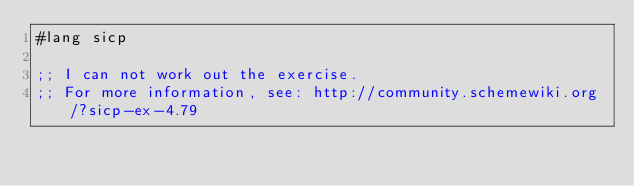<code> <loc_0><loc_0><loc_500><loc_500><_Scheme_>#lang sicp

;; I can not work out the exercise.
;; For more information, see: http://community.schemewiki.org/?sicp-ex-4.79
</code> 